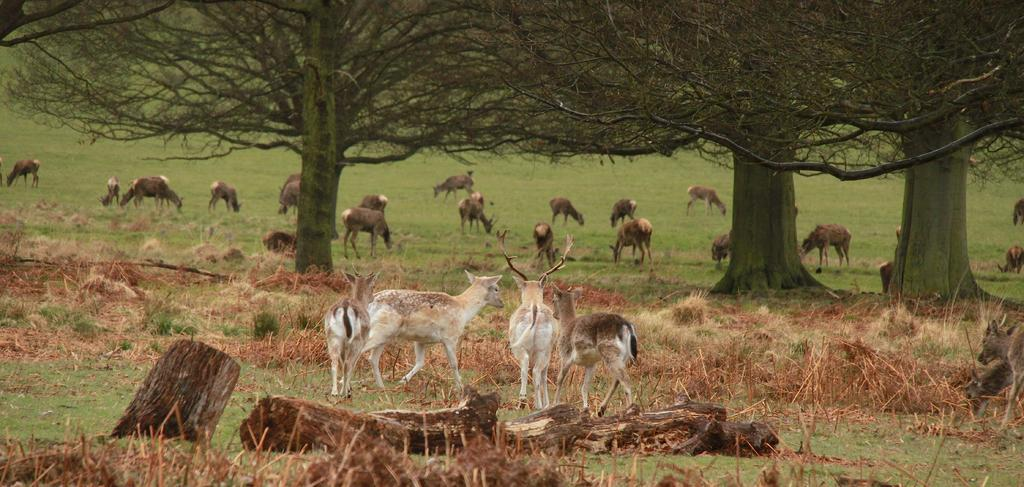What animals are present in the image? There are deers in the image. Where are the deers located in the image? The deers are in the center of the image, and there are more deers at the bottom side of the image. What can be seen in the background of the image? There is grassland and trees in the background of the image. Is there any quicksand visible in the image? No, there is no quicksand present in the image. What type of development can be seen in the image? There is no development visible in the image; it features deers in a natural setting with grassland and trees in the background. 